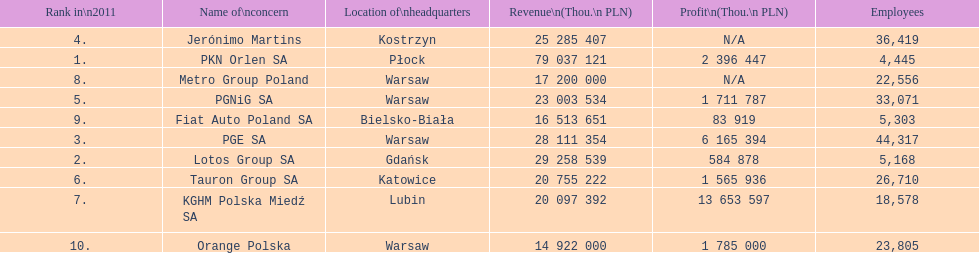What is the number of employees who work for pgnig sa? 33,071. 